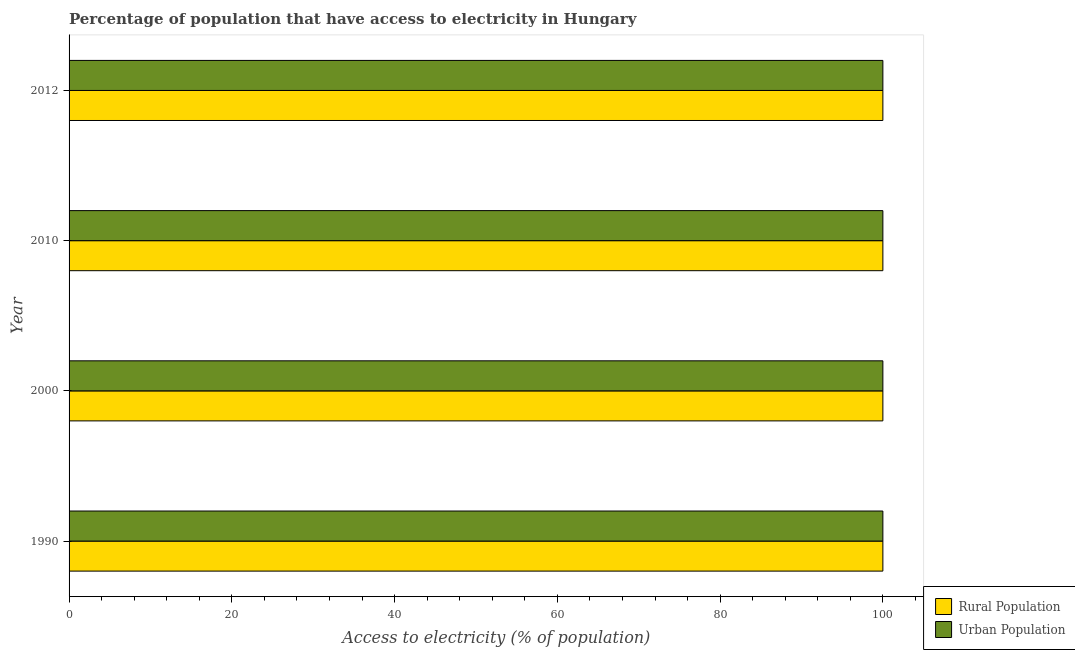How many different coloured bars are there?
Offer a very short reply. 2. How many bars are there on the 2nd tick from the bottom?
Give a very brief answer. 2. What is the label of the 3rd group of bars from the top?
Keep it short and to the point. 2000. In how many cases, is the number of bars for a given year not equal to the number of legend labels?
Provide a succinct answer. 0. What is the percentage of rural population having access to electricity in 1990?
Provide a succinct answer. 100. Across all years, what is the maximum percentage of urban population having access to electricity?
Keep it short and to the point. 100. Across all years, what is the minimum percentage of urban population having access to electricity?
Keep it short and to the point. 100. In which year was the percentage of urban population having access to electricity maximum?
Ensure brevity in your answer.  1990. In which year was the percentage of rural population having access to electricity minimum?
Your answer should be very brief. 1990. What is the total percentage of urban population having access to electricity in the graph?
Ensure brevity in your answer.  400. What is the average percentage of rural population having access to electricity per year?
Your answer should be very brief. 100. In the year 2012, what is the difference between the percentage of urban population having access to electricity and percentage of rural population having access to electricity?
Give a very brief answer. 0. In how many years, is the percentage of rural population having access to electricity greater than 36 %?
Provide a short and direct response. 4. What is the ratio of the percentage of urban population having access to electricity in 1990 to that in 2012?
Provide a short and direct response. 1. What is the difference between the highest and the second highest percentage of rural population having access to electricity?
Provide a short and direct response. 0. What is the difference between the highest and the lowest percentage of urban population having access to electricity?
Keep it short and to the point. 0. In how many years, is the percentage of rural population having access to electricity greater than the average percentage of rural population having access to electricity taken over all years?
Provide a succinct answer. 0. Is the sum of the percentage of urban population having access to electricity in 1990 and 2010 greater than the maximum percentage of rural population having access to electricity across all years?
Keep it short and to the point. Yes. What does the 1st bar from the top in 1990 represents?
Your answer should be very brief. Urban Population. What does the 1st bar from the bottom in 2010 represents?
Ensure brevity in your answer.  Rural Population. How many bars are there?
Your answer should be compact. 8. What is the difference between two consecutive major ticks on the X-axis?
Your answer should be very brief. 20. Does the graph contain any zero values?
Your answer should be very brief. No. Does the graph contain grids?
Provide a succinct answer. No. What is the title of the graph?
Provide a short and direct response. Percentage of population that have access to electricity in Hungary. Does "Foreign Liabilities" appear as one of the legend labels in the graph?
Your answer should be very brief. No. What is the label or title of the X-axis?
Your answer should be compact. Access to electricity (% of population). What is the label or title of the Y-axis?
Ensure brevity in your answer.  Year. What is the Access to electricity (% of population) of Urban Population in 2012?
Make the answer very short. 100. What is the total Access to electricity (% of population) of Rural Population in the graph?
Keep it short and to the point. 400. What is the total Access to electricity (% of population) in Urban Population in the graph?
Your response must be concise. 400. What is the difference between the Access to electricity (% of population) in Urban Population in 1990 and that in 2000?
Offer a terse response. 0. What is the difference between the Access to electricity (% of population) in Rural Population in 1990 and that in 2010?
Offer a very short reply. 0. What is the difference between the Access to electricity (% of population) in Urban Population in 1990 and that in 2010?
Make the answer very short. 0. What is the difference between the Access to electricity (% of population) in Rural Population in 1990 and that in 2012?
Keep it short and to the point. 0. What is the difference between the Access to electricity (% of population) of Rural Population in 2000 and that in 2010?
Offer a terse response. 0. What is the difference between the Access to electricity (% of population) in Rural Population in 2010 and that in 2012?
Keep it short and to the point. 0. What is the difference between the Access to electricity (% of population) in Rural Population in 1990 and the Access to electricity (% of population) in Urban Population in 2000?
Keep it short and to the point. 0. What is the difference between the Access to electricity (% of population) of Rural Population in 2000 and the Access to electricity (% of population) of Urban Population in 2012?
Keep it short and to the point. 0. What is the difference between the Access to electricity (% of population) of Rural Population in 2010 and the Access to electricity (% of population) of Urban Population in 2012?
Your response must be concise. 0. What is the average Access to electricity (% of population) of Rural Population per year?
Keep it short and to the point. 100. What is the average Access to electricity (% of population) of Urban Population per year?
Provide a short and direct response. 100. In the year 2010, what is the difference between the Access to electricity (% of population) in Rural Population and Access to electricity (% of population) in Urban Population?
Give a very brief answer. 0. What is the ratio of the Access to electricity (% of population) of Urban Population in 1990 to that in 2010?
Your answer should be very brief. 1. What is the ratio of the Access to electricity (% of population) in Rural Population in 1990 to that in 2012?
Your answer should be very brief. 1. What is the ratio of the Access to electricity (% of population) in Urban Population in 1990 to that in 2012?
Your answer should be very brief. 1. What is the ratio of the Access to electricity (% of population) of Rural Population in 2010 to that in 2012?
Your answer should be compact. 1. 